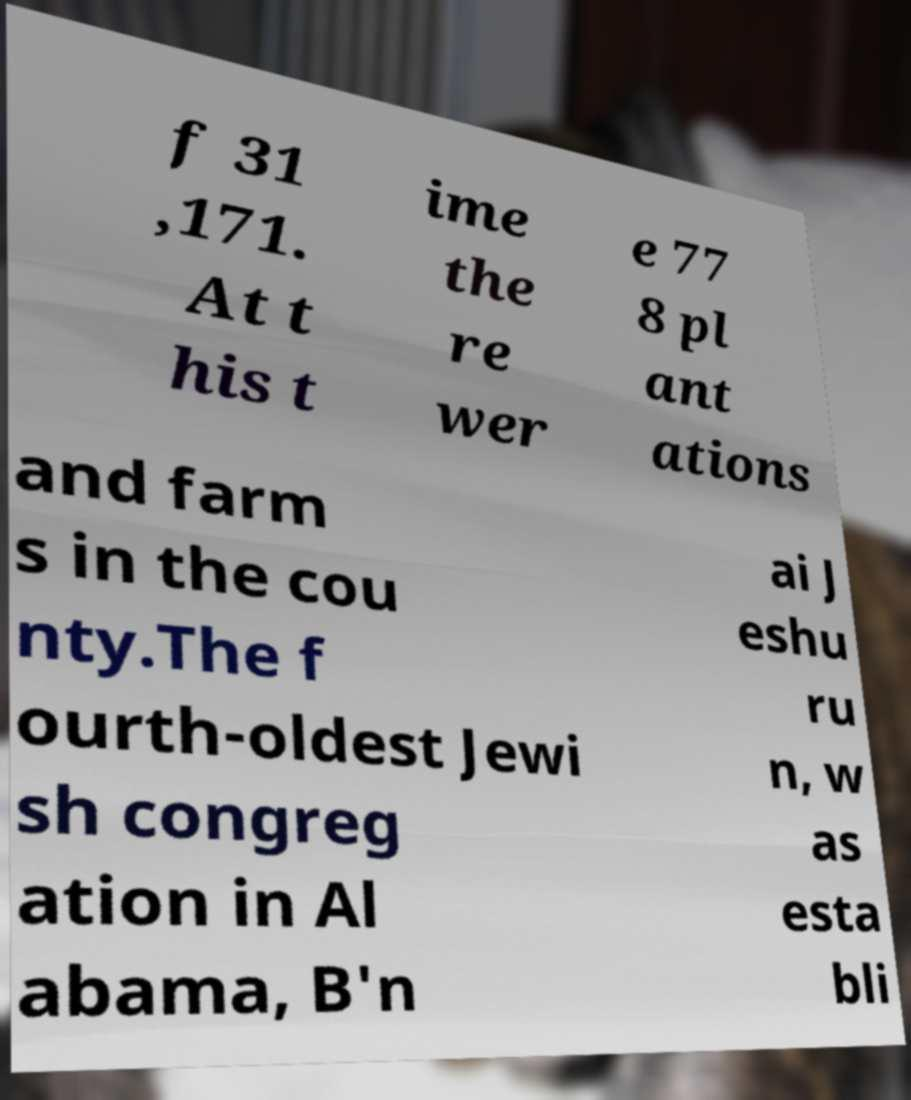Could you assist in decoding the text presented in this image and type it out clearly? f 31 ,171. At t his t ime the re wer e 77 8 pl ant ations and farm s in the cou nty.The f ourth-oldest Jewi sh congreg ation in Al abama, B'n ai J eshu ru n, w as esta bli 